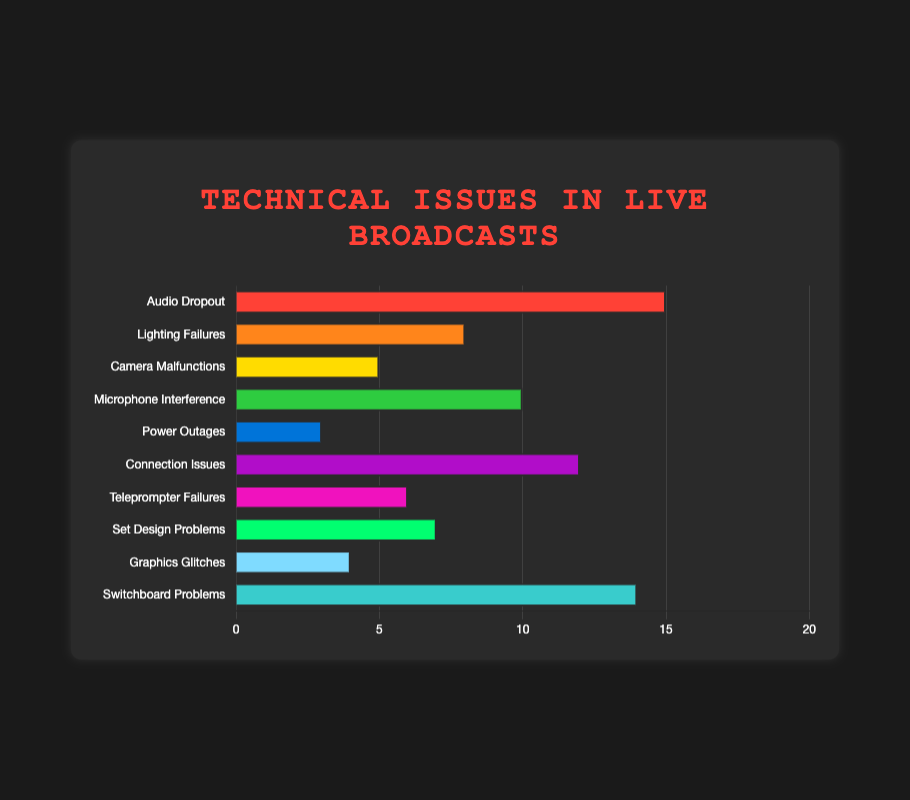What type of technical issue has the highest frequency? The bar for "Audio Dropout" is the longest, indicating it has the highest frequency.
Answer: Audio Dropout Which two types of technical issues have a frequency difference of 9? "Audio Dropout" has a frequency of 15, and "Power Outages" has a frequency of 3. The difference is 15 - 3 = 12. "Microphone Interference" has a frequency of 10, and "Graphics Glitches" has a frequency of 4. The difference is 10 - 4 = 6. "Switchboard Problems" has a frequency of 14 and "Set Design Problems" has a frequency of 7, the difference is 14 - 7 = 7. After checking all pairings, only "Audio Dropout" and "Power Outages"  matches the given difference.
Answer: Audio Dropout and Power Outages Which technical issue frequency is the closest to the median value? To find the median, we arrange the frequencies in ascending order: [3, 4, 5, 6, 7, 8, 10, 12, 14, 15]. The median (middle value) for these 10 items is the average of the 5th and 6th values: (7 + 8) / 2 = 7.5. "Lighting Failures" has a frequency of 8, closest to 7.5.
Answer: Lighting Failures Which technical issue is represented by the green bar? The green bar corresponds to "Microphone Interference".
Answer: Microphone Interference If the frequencies of "Lighting Failures" and "Microphone Interference" are combined, what is the new total? Adding the frequencies: Lighting Failures (8) + Microphone Interference (10) = 18
Answer: 18 How many technical issues have a frequency of at least 10? The bars with frequencies of at least 10 are: "Audio Dropout" (15), "Switchboard Problems" (14), and "Connection Issues" (12). Therefore, there are 3 technical issues.
Answer: 3 Which technical issue has the lowest frequency? The shortest bar represents "Power Outages", which has a frequency of 3.
Answer: Power Outages By how much does the frequency of "Camera Malfunctions" differ from "Graphics Glitches"? The frequency of "Camera Malfunctions" is 5, and that of "Graphics Glitches" is 4. The difference is 5 - 4 = 1.
Answer: 1 What is the total frequency for all technical issues combined? Summing all the frequencies: 15 + 8 + 5 + 10 + 3 + 12 + 6 + 7 + 4 + 14 = 84
Answer: 84 